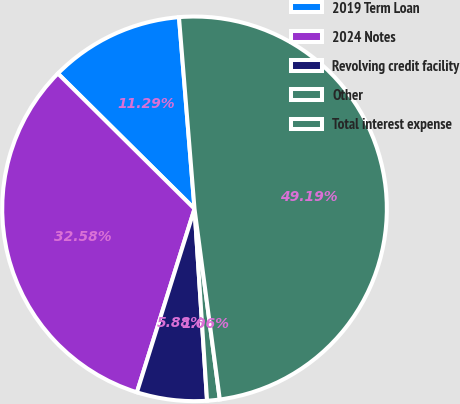<chart> <loc_0><loc_0><loc_500><loc_500><pie_chart><fcel>2019 Term Loan<fcel>2024 Notes<fcel>Revolving credit facility<fcel>Other<fcel>Total interest expense<nl><fcel>11.29%<fcel>32.58%<fcel>5.88%<fcel>1.06%<fcel>49.19%<nl></chart> 